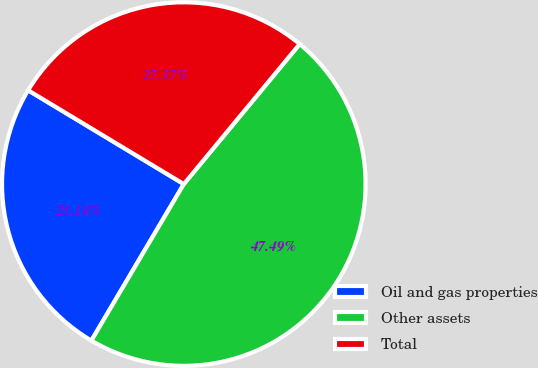<chart> <loc_0><loc_0><loc_500><loc_500><pie_chart><fcel>Oil and gas properties<fcel>Other assets<fcel>Total<nl><fcel>25.14%<fcel>47.49%<fcel>27.37%<nl></chart> 